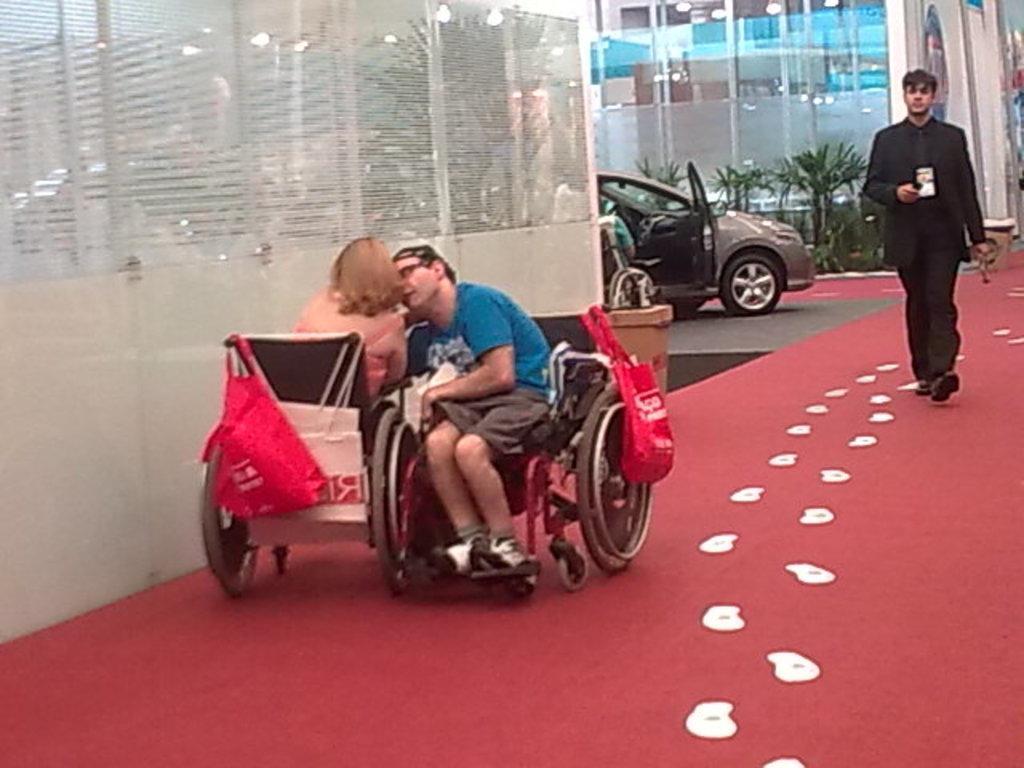Describe this image in one or two sentences. In this picture we can observe two members in the wheel chairs who were in opposite directions. One of them was a man and the other was a woman. There are two red color covers hanged to their chairs. On the right side there is a man walking. We can observe a car parked on the floor. In the background there are some plants. 